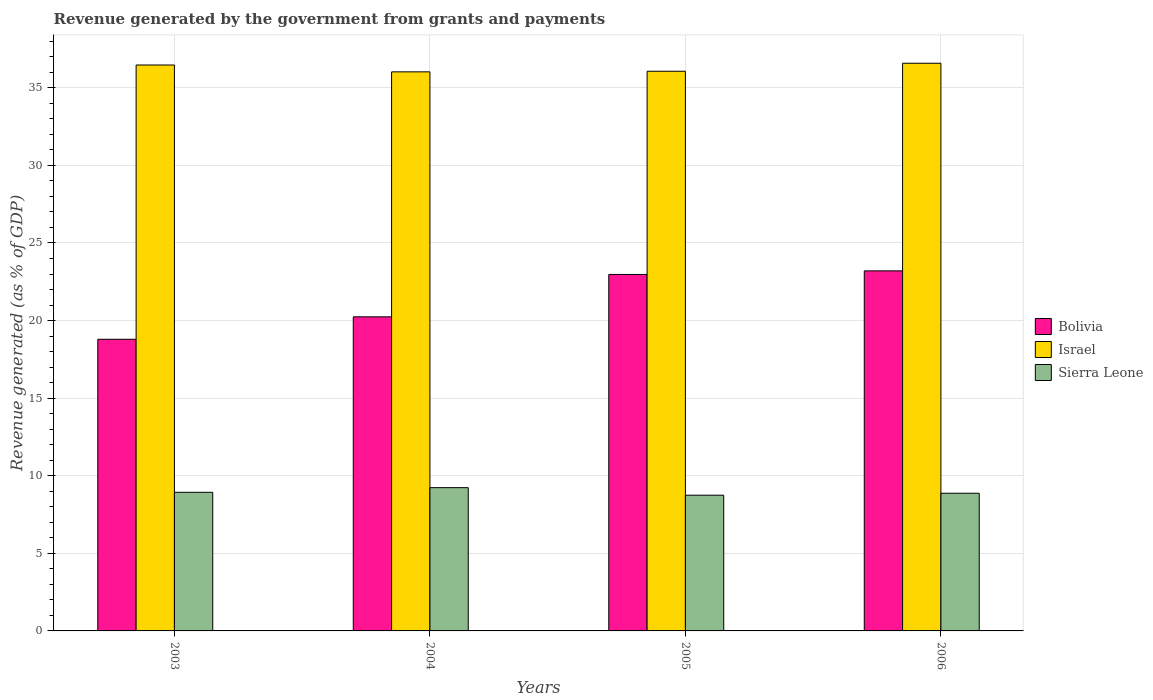How many different coloured bars are there?
Your answer should be very brief. 3. Are the number of bars on each tick of the X-axis equal?
Ensure brevity in your answer.  Yes. What is the label of the 4th group of bars from the left?
Ensure brevity in your answer.  2006. What is the revenue generated by the government in Sierra Leone in 2006?
Keep it short and to the point. 8.87. Across all years, what is the maximum revenue generated by the government in Bolivia?
Provide a short and direct response. 23.2. Across all years, what is the minimum revenue generated by the government in Sierra Leone?
Provide a short and direct response. 8.75. In which year was the revenue generated by the government in Israel maximum?
Give a very brief answer. 2006. In which year was the revenue generated by the government in Israel minimum?
Your response must be concise. 2004. What is the total revenue generated by the government in Sierra Leone in the graph?
Offer a very short reply. 35.79. What is the difference between the revenue generated by the government in Israel in 2003 and that in 2004?
Offer a terse response. 0.44. What is the difference between the revenue generated by the government in Bolivia in 2005 and the revenue generated by the government in Israel in 2004?
Your answer should be very brief. -13.06. What is the average revenue generated by the government in Sierra Leone per year?
Make the answer very short. 8.95. In the year 2005, what is the difference between the revenue generated by the government in Sierra Leone and revenue generated by the government in Bolivia?
Your response must be concise. -14.23. In how many years, is the revenue generated by the government in Sierra Leone greater than 24 %?
Provide a succinct answer. 0. What is the ratio of the revenue generated by the government in Sierra Leone in 2003 to that in 2005?
Your answer should be very brief. 1.02. What is the difference between the highest and the second highest revenue generated by the government in Bolivia?
Make the answer very short. 0.23. What is the difference between the highest and the lowest revenue generated by the government in Bolivia?
Your answer should be compact. 4.41. In how many years, is the revenue generated by the government in Israel greater than the average revenue generated by the government in Israel taken over all years?
Your answer should be compact. 2. What does the 3rd bar from the left in 2005 represents?
Make the answer very short. Sierra Leone. What does the 1st bar from the right in 2004 represents?
Your response must be concise. Sierra Leone. Is it the case that in every year, the sum of the revenue generated by the government in Sierra Leone and revenue generated by the government in Israel is greater than the revenue generated by the government in Bolivia?
Your response must be concise. Yes. Are all the bars in the graph horizontal?
Your response must be concise. No. Does the graph contain any zero values?
Ensure brevity in your answer.  No. Does the graph contain grids?
Provide a short and direct response. Yes. Where does the legend appear in the graph?
Provide a short and direct response. Center right. How many legend labels are there?
Give a very brief answer. 3. What is the title of the graph?
Your answer should be very brief. Revenue generated by the government from grants and payments. Does "Venezuela" appear as one of the legend labels in the graph?
Keep it short and to the point. No. What is the label or title of the X-axis?
Make the answer very short. Years. What is the label or title of the Y-axis?
Give a very brief answer. Revenue generated (as % of GDP). What is the Revenue generated (as % of GDP) in Bolivia in 2003?
Ensure brevity in your answer.  18.8. What is the Revenue generated (as % of GDP) of Israel in 2003?
Your response must be concise. 36.47. What is the Revenue generated (as % of GDP) in Sierra Leone in 2003?
Keep it short and to the point. 8.93. What is the Revenue generated (as % of GDP) in Bolivia in 2004?
Your answer should be compact. 20.24. What is the Revenue generated (as % of GDP) in Israel in 2004?
Make the answer very short. 36.03. What is the Revenue generated (as % of GDP) in Sierra Leone in 2004?
Give a very brief answer. 9.23. What is the Revenue generated (as % of GDP) of Bolivia in 2005?
Ensure brevity in your answer.  22.97. What is the Revenue generated (as % of GDP) of Israel in 2005?
Offer a very short reply. 36.07. What is the Revenue generated (as % of GDP) in Sierra Leone in 2005?
Your answer should be compact. 8.75. What is the Revenue generated (as % of GDP) of Bolivia in 2006?
Give a very brief answer. 23.2. What is the Revenue generated (as % of GDP) of Israel in 2006?
Your answer should be compact. 36.58. What is the Revenue generated (as % of GDP) in Sierra Leone in 2006?
Offer a very short reply. 8.87. Across all years, what is the maximum Revenue generated (as % of GDP) of Bolivia?
Your response must be concise. 23.2. Across all years, what is the maximum Revenue generated (as % of GDP) of Israel?
Offer a very short reply. 36.58. Across all years, what is the maximum Revenue generated (as % of GDP) in Sierra Leone?
Give a very brief answer. 9.23. Across all years, what is the minimum Revenue generated (as % of GDP) of Bolivia?
Ensure brevity in your answer.  18.8. Across all years, what is the minimum Revenue generated (as % of GDP) of Israel?
Ensure brevity in your answer.  36.03. Across all years, what is the minimum Revenue generated (as % of GDP) in Sierra Leone?
Give a very brief answer. 8.75. What is the total Revenue generated (as % of GDP) of Bolivia in the graph?
Your answer should be very brief. 85.21. What is the total Revenue generated (as % of GDP) in Israel in the graph?
Your answer should be compact. 145.15. What is the total Revenue generated (as % of GDP) in Sierra Leone in the graph?
Provide a succinct answer. 35.79. What is the difference between the Revenue generated (as % of GDP) in Bolivia in 2003 and that in 2004?
Your answer should be very brief. -1.45. What is the difference between the Revenue generated (as % of GDP) of Israel in 2003 and that in 2004?
Provide a succinct answer. 0.44. What is the difference between the Revenue generated (as % of GDP) of Sierra Leone in 2003 and that in 2004?
Give a very brief answer. -0.3. What is the difference between the Revenue generated (as % of GDP) of Bolivia in 2003 and that in 2005?
Ensure brevity in your answer.  -4.18. What is the difference between the Revenue generated (as % of GDP) in Israel in 2003 and that in 2005?
Your answer should be very brief. 0.4. What is the difference between the Revenue generated (as % of GDP) in Sierra Leone in 2003 and that in 2005?
Ensure brevity in your answer.  0.19. What is the difference between the Revenue generated (as % of GDP) in Bolivia in 2003 and that in 2006?
Offer a terse response. -4.41. What is the difference between the Revenue generated (as % of GDP) in Israel in 2003 and that in 2006?
Provide a short and direct response. -0.11. What is the difference between the Revenue generated (as % of GDP) of Sierra Leone in 2003 and that in 2006?
Offer a terse response. 0.06. What is the difference between the Revenue generated (as % of GDP) of Bolivia in 2004 and that in 2005?
Offer a terse response. -2.73. What is the difference between the Revenue generated (as % of GDP) of Israel in 2004 and that in 2005?
Give a very brief answer. -0.04. What is the difference between the Revenue generated (as % of GDP) in Sierra Leone in 2004 and that in 2005?
Ensure brevity in your answer.  0.49. What is the difference between the Revenue generated (as % of GDP) in Bolivia in 2004 and that in 2006?
Make the answer very short. -2.96. What is the difference between the Revenue generated (as % of GDP) in Israel in 2004 and that in 2006?
Give a very brief answer. -0.55. What is the difference between the Revenue generated (as % of GDP) in Sierra Leone in 2004 and that in 2006?
Your answer should be very brief. 0.36. What is the difference between the Revenue generated (as % of GDP) in Bolivia in 2005 and that in 2006?
Make the answer very short. -0.23. What is the difference between the Revenue generated (as % of GDP) in Israel in 2005 and that in 2006?
Offer a terse response. -0.51. What is the difference between the Revenue generated (as % of GDP) of Sierra Leone in 2005 and that in 2006?
Keep it short and to the point. -0.13. What is the difference between the Revenue generated (as % of GDP) of Bolivia in 2003 and the Revenue generated (as % of GDP) of Israel in 2004?
Your answer should be very brief. -17.23. What is the difference between the Revenue generated (as % of GDP) of Bolivia in 2003 and the Revenue generated (as % of GDP) of Sierra Leone in 2004?
Your answer should be very brief. 9.56. What is the difference between the Revenue generated (as % of GDP) in Israel in 2003 and the Revenue generated (as % of GDP) in Sierra Leone in 2004?
Keep it short and to the point. 27.24. What is the difference between the Revenue generated (as % of GDP) in Bolivia in 2003 and the Revenue generated (as % of GDP) in Israel in 2005?
Provide a succinct answer. -17.27. What is the difference between the Revenue generated (as % of GDP) of Bolivia in 2003 and the Revenue generated (as % of GDP) of Sierra Leone in 2005?
Keep it short and to the point. 10.05. What is the difference between the Revenue generated (as % of GDP) in Israel in 2003 and the Revenue generated (as % of GDP) in Sierra Leone in 2005?
Make the answer very short. 27.72. What is the difference between the Revenue generated (as % of GDP) of Bolivia in 2003 and the Revenue generated (as % of GDP) of Israel in 2006?
Ensure brevity in your answer.  -17.79. What is the difference between the Revenue generated (as % of GDP) in Bolivia in 2003 and the Revenue generated (as % of GDP) in Sierra Leone in 2006?
Keep it short and to the point. 9.92. What is the difference between the Revenue generated (as % of GDP) of Israel in 2003 and the Revenue generated (as % of GDP) of Sierra Leone in 2006?
Your answer should be compact. 27.6. What is the difference between the Revenue generated (as % of GDP) of Bolivia in 2004 and the Revenue generated (as % of GDP) of Israel in 2005?
Keep it short and to the point. -15.83. What is the difference between the Revenue generated (as % of GDP) of Bolivia in 2004 and the Revenue generated (as % of GDP) of Sierra Leone in 2005?
Make the answer very short. 11.49. What is the difference between the Revenue generated (as % of GDP) of Israel in 2004 and the Revenue generated (as % of GDP) of Sierra Leone in 2005?
Provide a short and direct response. 27.28. What is the difference between the Revenue generated (as % of GDP) of Bolivia in 2004 and the Revenue generated (as % of GDP) of Israel in 2006?
Provide a short and direct response. -16.34. What is the difference between the Revenue generated (as % of GDP) of Bolivia in 2004 and the Revenue generated (as % of GDP) of Sierra Leone in 2006?
Your answer should be compact. 11.37. What is the difference between the Revenue generated (as % of GDP) in Israel in 2004 and the Revenue generated (as % of GDP) in Sierra Leone in 2006?
Keep it short and to the point. 27.16. What is the difference between the Revenue generated (as % of GDP) in Bolivia in 2005 and the Revenue generated (as % of GDP) in Israel in 2006?
Your answer should be compact. -13.61. What is the difference between the Revenue generated (as % of GDP) of Bolivia in 2005 and the Revenue generated (as % of GDP) of Sierra Leone in 2006?
Ensure brevity in your answer.  14.1. What is the difference between the Revenue generated (as % of GDP) in Israel in 2005 and the Revenue generated (as % of GDP) in Sierra Leone in 2006?
Give a very brief answer. 27.2. What is the average Revenue generated (as % of GDP) of Bolivia per year?
Your answer should be compact. 21.3. What is the average Revenue generated (as % of GDP) in Israel per year?
Provide a succinct answer. 36.29. What is the average Revenue generated (as % of GDP) in Sierra Leone per year?
Your answer should be very brief. 8.95. In the year 2003, what is the difference between the Revenue generated (as % of GDP) of Bolivia and Revenue generated (as % of GDP) of Israel?
Offer a very short reply. -17.68. In the year 2003, what is the difference between the Revenue generated (as % of GDP) in Bolivia and Revenue generated (as % of GDP) in Sierra Leone?
Give a very brief answer. 9.86. In the year 2003, what is the difference between the Revenue generated (as % of GDP) in Israel and Revenue generated (as % of GDP) in Sierra Leone?
Your answer should be compact. 27.54. In the year 2004, what is the difference between the Revenue generated (as % of GDP) in Bolivia and Revenue generated (as % of GDP) in Israel?
Offer a very short reply. -15.79. In the year 2004, what is the difference between the Revenue generated (as % of GDP) in Bolivia and Revenue generated (as % of GDP) in Sierra Leone?
Your answer should be compact. 11.01. In the year 2004, what is the difference between the Revenue generated (as % of GDP) in Israel and Revenue generated (as % of GDP) in Sierra Leone?
Provide a succinct answer. 26.8. In the year 2005, what is the difference between the Revenue generated (as % of GDP) in Bolivia and Revenue generated (as % of GDP) in Israel?
Keep it short and to the point. -13.1. In the year 2005, what is the difference between the Revenue generated (as % of GDP) of Bolivia and Revenue generated (as % of GDP) of Sierra Leone?
Provide a short and direct response. 14.22. In the year 2005, what is the difference between the Revenue generated (as % of GDP) in Israel and Revenue generated (as % of GDP) in Sierra Leone?
Offer a very short reply. 27.32. In the year 2006, what is the difference between the Revenue generated (as % of GDP) of Bolivia and Revenue generated (as % of GDP) of Israel?
Offer a terse response. -13.38. In the year 2006, what is the difference between the Revenue generated (as % of GDP) in Bolivia and Revenue generated (as % of GDP) in Sierra Leone?
Provide a succinct answer. 14.33. In the year 2006, what is the difference between the Revenue generated (as % of GDP) of Israel and Revenue generated (as % of GDP) of Sierra Leone?
Your answer should be compact. 27.71. What is the ratio of the Revenue generated (as % of GDP) in Bolivia in 2003 to that in 2004?
Provide a short and direct response. 0.93. What is the ratio of the Revenue generated (as % of GDP) of Israel in 2003 to that in 2004?
Provide a succinct answer. 1.01. What is the ratio of the Revenue generated (as % of GDP) of Sierra Leone in 2003 to that in 2004?
Provide a succinct answer. 0.97. What is the ratio of the Revenue generated (as % of GDP) in Bolivia in 2003 to that in 2005?
Offer a terse response. 0.82. What is the ratio of the Revenue generated (as % of GDP) of Israel in 2003 to that in 2005?
Keep it short and to the point. 1.01. What is the ratio of the Revenue generated (as % of GDP) of Sierra Leone in 2003 to that in 2005?
Provide a succinct answer. 1.02. What is the ratio of the Revenue generated (as % of GDP) of Bolivia in 2003 to that in 2006?
Provide a short and direct response. 0.81. What is the ratio of the Revenue generated (as % of GDP) of Sierra Leone in 2003 to that in 2006?
Offer a terse response. 1.01. What is the ratio of the Revenue generated (as % of GDP) in Bolivia in 2004 to that in 2005?
Offer a very short reply. 0.88. What is the ratio of the Revenue generated (as % of GDP) in Israel in 2004 to that in 2005?
Keep it short and to the point. 1. What is the ratio of the Revenue generated (as % of GDP) in Sierra Leone in 2004 to that in 2005?
Provide a short and direct response. 1.06. What is the ratio of the Revenue generated (as % of GDP) of Bolivia in 2004 to that in 2006?
Provide a succinct answer. 0.87. What is the ratio of the Revenue generated (as % of GDP) in Israel in 2004 to that in 2006?
Your response must be concise. 0.98. What is the ratio of the Revenue generated (as % of GDP) in Sierra Leone in 2004 to that in 2006?
Ensure brevity in your answer.  1.04. What is the ratio of the Revenue generated (as % of GDP) in Israel in 2005 to that in 2006?
Give a very brief answer. 0.99. What is the ratio of the Revenue generated (as % of GDP) in Sierra Leone in 2005 to that in 2006?
Your answer should be very brief. 0.99. What is the difference between the highest and the second highest Revenue generated (as % of GDP) in Bolivia?
Offer a terse response. 0.23. What is the difference between the highest and the second highest Revenue generated (as % of GDP) of Israel?
Provide a succinct answer. 0.11. What is the difference between the highest and the second highest Revenue generated (as % of GDP) in Sierra Leone?
Your answer should be compact. 0.3. What is the difference between the highest and the lowest Revenue generated (as % of GDP) in Bolivia?
Keep it short and to the point. 4.41. What is the difference between the highest and the lowest Revenue generated (as % of GDP) of Israel?
Give a very brief answer. 0.55. What is the difference between the highest and the lowest Revenue generated (as % of GDP) of Sierra Leone?
Provide a succinct answer. 0.49. 